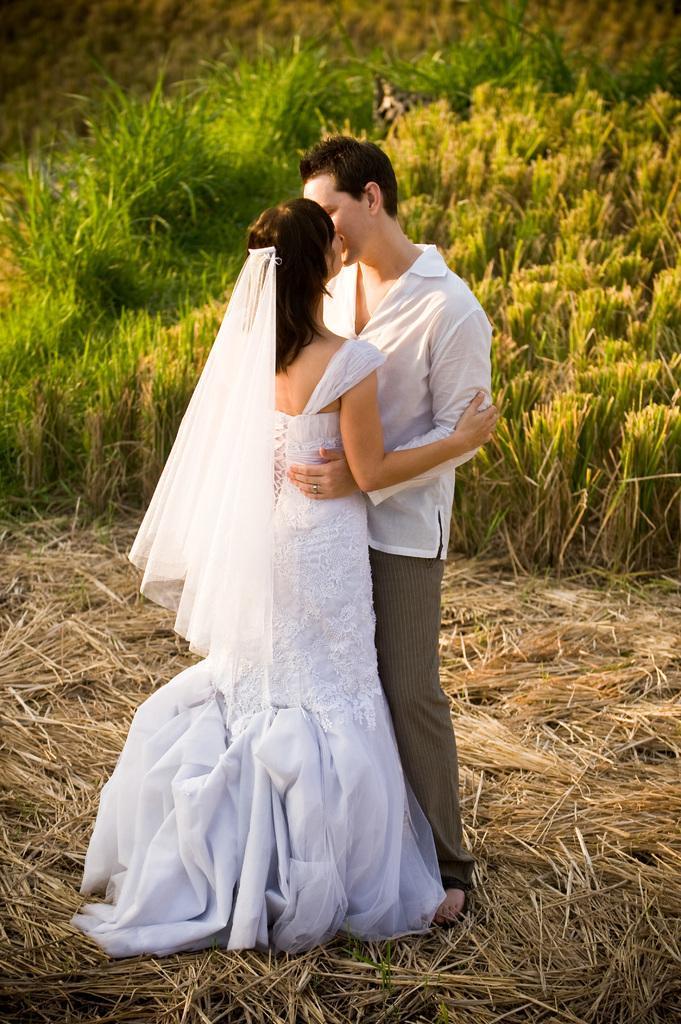In one or two sentences, can you explain what this image depicts? In the middle of the image we can see a man and woman, they both are standing, behind to them we can see few plants. 